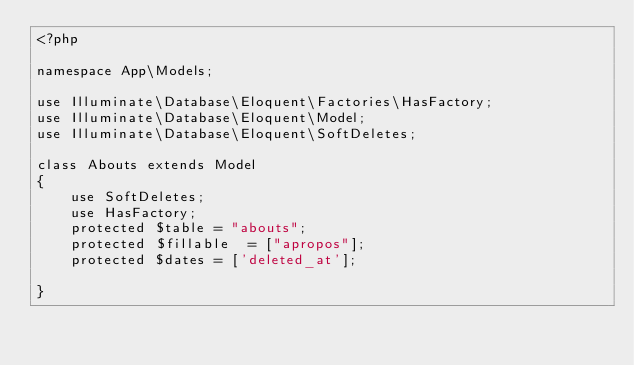<code> <loc_0><loc_0><loc_500><loc_500><_PHP_><?php

namespace App\Models;

use Illuminate\Database\Eloquent\Factories\HasFactory;
use Illuminate\Database\Eloquent\Model;
use Illuminate\Database\Eloquent\SoftDeletes;

class Abouts extends Model
{
    use SoftDeletes;
    use HasFactory;
    protected $table = "abouts";
    protected $fillable  = ["apropos"];
    protected $dates = ['deleted_at'];

}
</code> 